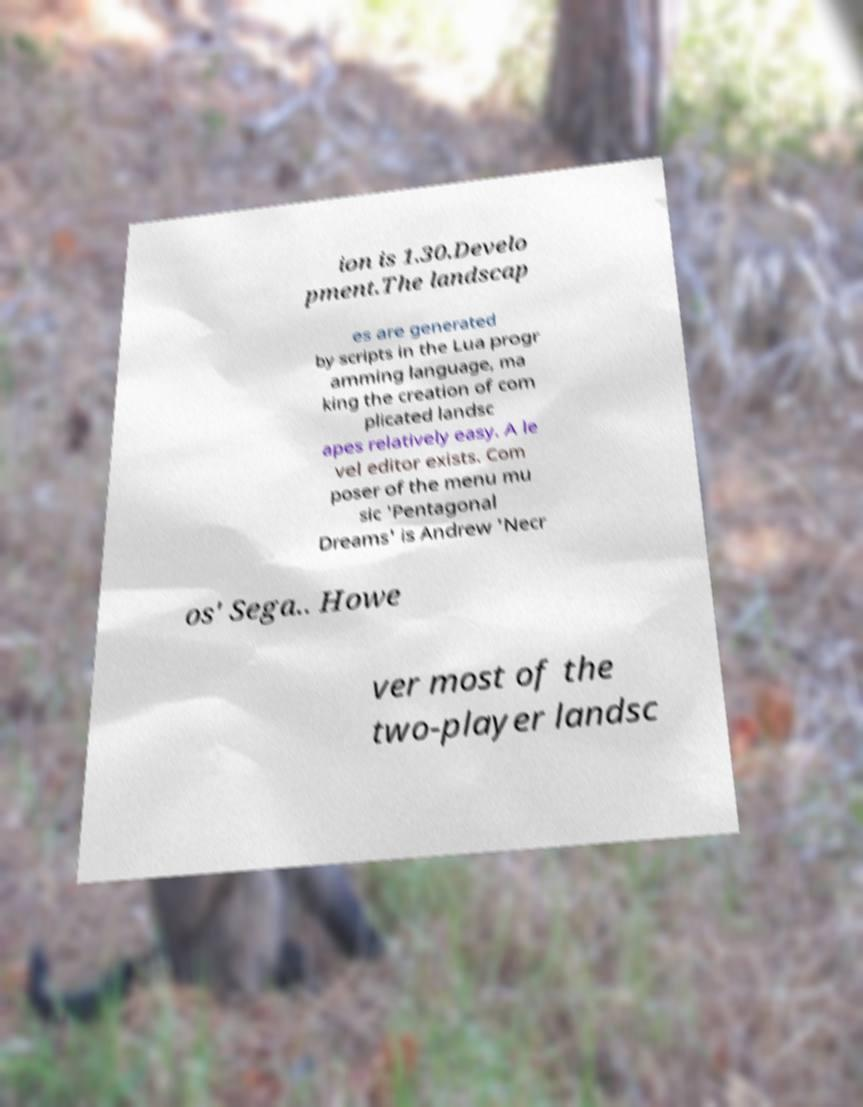Could you assist in decoding the text presented in this image and type it out clearly? ion is 1.30.Develo pment.The landscap es are generated by scripts in the Lua progr amming language, ma king the creation of com plicated landsc apes relatively easy. A le vel editor exists. Com poser of the menu mu sic 'Pentagonal Dreams' is Andrew 'Necr os' Sega.. Howe ver most of the two-player landsc 